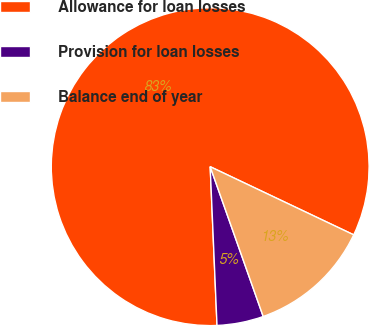Convert chart. <chart><loc_0><loc_0><loc_500><loc_500><pie_chart><fcel>Allowance for loan losses<fcel>Provision for loan losses<fcel>Balance end of year<nl><fcel>82.74%<fcel>4.73%<fcel>12.53%<nl></chart> 